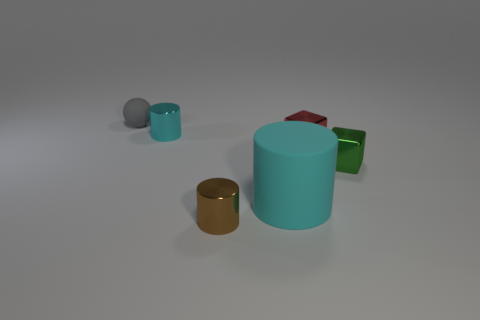There is a small cylinder that is to the left of the small cylinder in front of the small cyan cylinder that is behind the small red object; what is it made of?
Give a very brief answer. Metal. Does the tiny rubber object have the same shape as the small brown metal object?
Your answer should be very brief. No. What is the material of the other object that is the same shape as the green object?
Keep it short and to the point. Metal. Is the number of tiny cyan metal things that are behind the tiny green metal block greater than the number of gray matte spheres in front of the matte cylinder?
Your answer should be compact. Yes. What material is the small gray object?
Your answer should be compact. Rubber. Is there a gray matte object of the same size as the cyan metallic cylinder?
Provide a short and direct response. Yes. What is the material of the ball that is the same size as the red object?
Your answer should be very brief. Rubber. How many yellow rubber cylinders are there?
Give a very brief answer. 0. There is a cyan object that is on the left side of the brown cylinder; what size is it?
Offer a very short reply. Small. Is the number of green things behind the small cyan cylinder the same as the number of red shiny cylinders?
Give a very brief answer. Yes. 